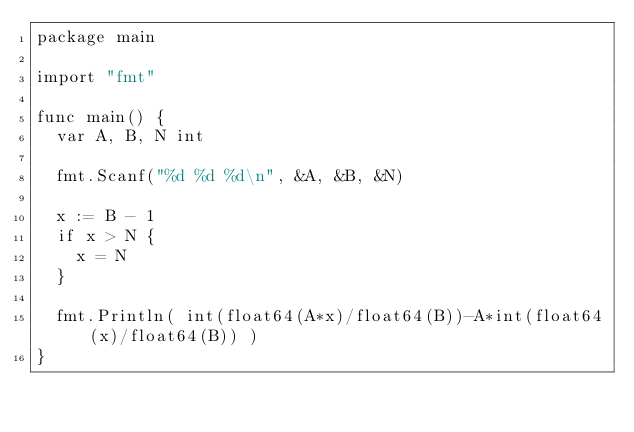<code> <loc_0><loc_0><loc_500><loc_500><_Go_>package main

import "fmt"

func main() {
  var A, B, N int
  
  fmt.Scanf("%d %d %d\n", &A, &B, &N)
  
  x := B - 1
  if x > N {
    x = N
  }
  
  fmt.Println( int(float64(A*x)/float64(B))-A*int(float64(x)/float64(B)) )
}
</code> 